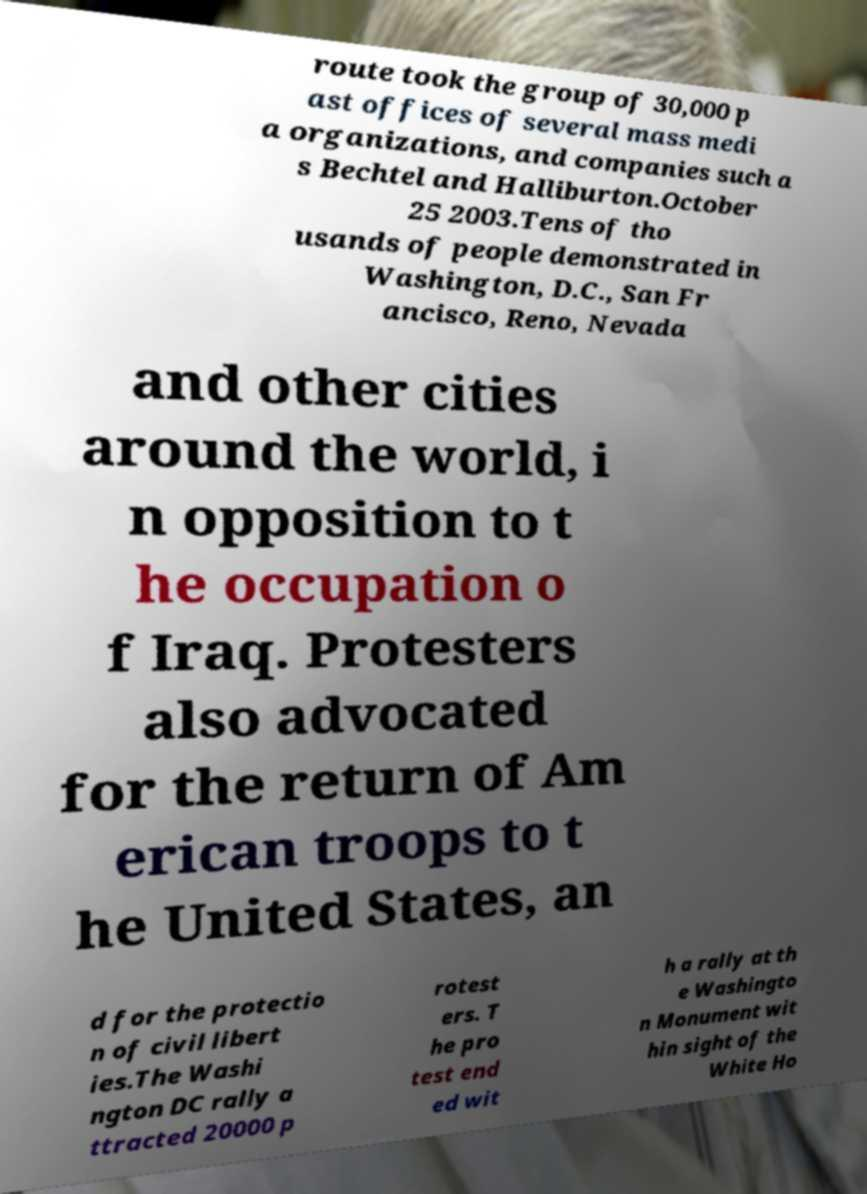There's text embedded in this image that I need extracted. Can you transcribe it verbatim? route took the group of 30,000 p ast offices of several mass medi a organizations, and companies such a s Bechtel and Halliburton.October 25 2003.Tens of tho usands of people demonstrated in Washington, D.C., San Fr ancisco, Reno, Nevada and other cities around the world, i n opposition to t he occupation o f Iraq. Protesters also advocated for the return of Am erican troops to t he United States, an d for the protectio n of civil libert ies.The Washi ngton DC rally a ttracted 20000 p rotest ers. T he pro test end ed wit h a rally at th e Washingto n Monument wit hin sight of the White Ho 